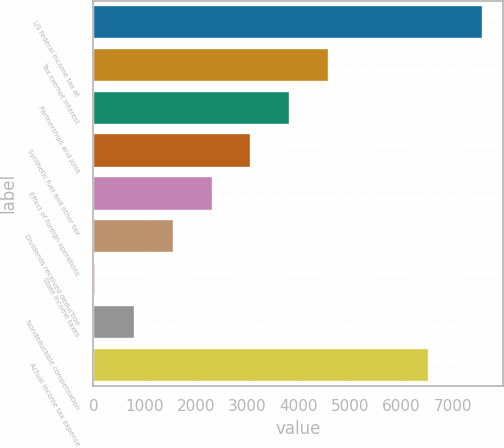<chart> <loc_0><loc_0><loc_500><loc_500><bar_chart><fcel>US federal income tax at<fcel>Tax exempt interest<fcel>Partnerships and joint<fcel>Synthetic fuel and other tax<fcel>Effect of foreign operations<fcel>Dividends received deduction<fcel>State income taxes<fcel>Nondeductible compensation<fcel>Actual income tax expense<nl><fcel>7591<fcel>4578.2<fcel>3825<fcel>3071.8<fcel>2318.6<fcel>1565.4<fcel>59<fcel>812.2<fcel>6537<nl></chart> 